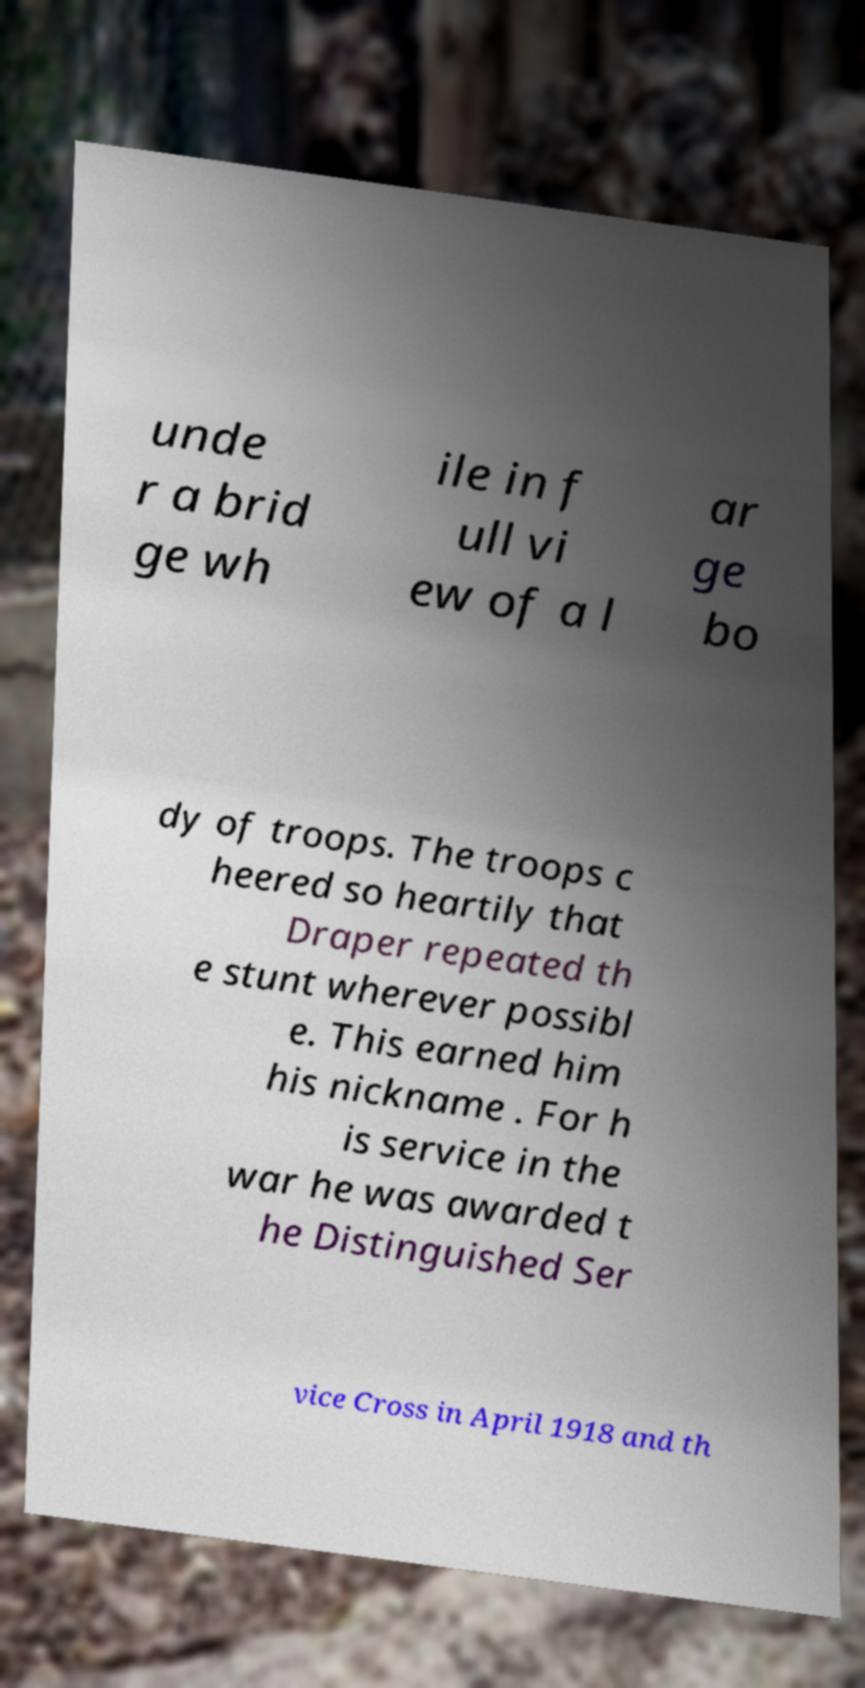I need the written content from this picture converted into text. Can you do that? unde r a brid ge wh ile in f ull vi ew of a l ar ge bo dy of troops. The troops c heered so heartily that Draper repeated th e stunt wherever possibl e. This earned him his nickname . For h is service in the war he was awarded t he Distinguished Ser vice Cross in April 1918 and th 